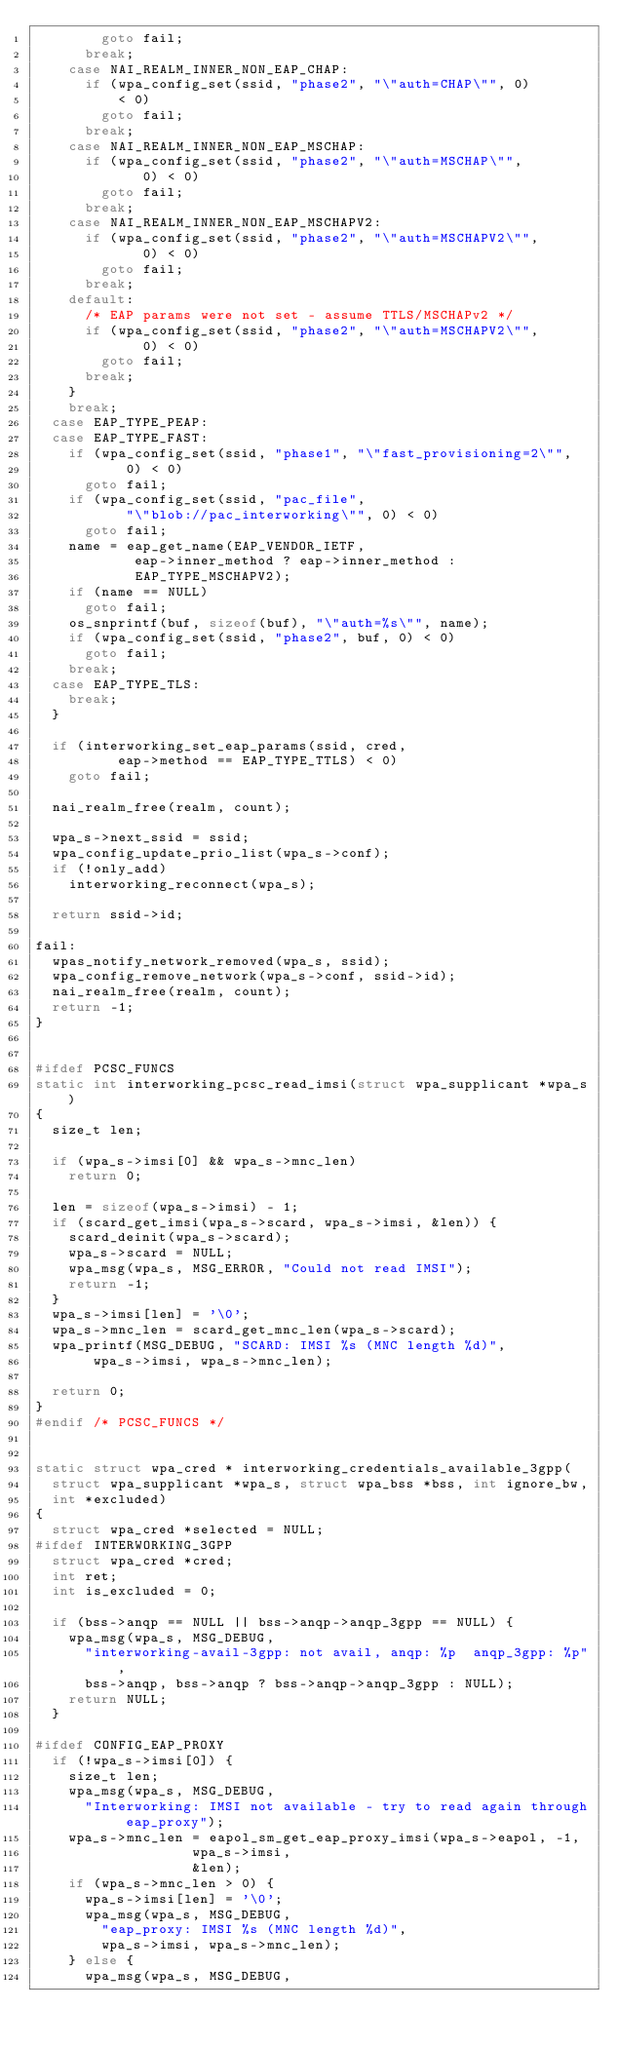Convert code to text. <code><loc_0><loc_0><loc_500><loc_500><_C_>				goto fail;
			break;
		case NAI_REALM_INNER_NON_EAP_CHAP:
			if (wpa_config_set(ssid, "phase2", "\"auth=CHAP\"", 0)
			    < 0)
				goto fail;
			break;
		case NAI_REALM_INNER_NON_EAP_MSCHAP:
			if (wpa_config_set(ssid, "phase2", "\"auth=MSCHAP\"",
					   0) < 0)
				goto fail;
			break;
		case NAI_REALM_INNER_NON_EAP_MSCHAPV2:
			if (wpa_config_set(ssid, "phase2", "\"auth=MSCHAPV2\"",
					   0) < 0)
				goto fail;
			break;
		default:
			/* EAP params were not set - assume TTLS/MSCHAPv2 */
			if (wpa_config_set(ssid, "phase2", "\"auth=MSCHAPV2\"",
					   0) < 0)
				goto fail;
			break;
		}
		break;
	case EAP_TYPE_PEAP:
	case EAP_TYPE_FAST:
		if (wpa_config_set(ssid, "phase1", "\"fast_provisioning=2\"",
				   0) < 0)
			goto fail;
		if (wpa_config_set(ssid, "pac_file",
				   "\"blob://pac_interworking\"", 0) < 0)
			goto fail;
		name = eap_get_name(EAP_VENDOR_IETF,
				    eap->inner_method ? eap->inner_method :
				    EAP_TYPE_MSCHAPV2);
		if (name == NULL)
			goto fail;
		os_snprintf(buf, sizeof(buf), "\"auth=%s\"", name);
		if (wpa_config_set(ssid, "phase2", buf, 0) < 0)
			goto fail;
		break;
	case EAP_TYPE_TLS:
		break;
	}

	if (interworking_set_eap_params(ssid, cred,
					eap->method == EAP_TYPE_TTLS) < 0)
		goto fail;

	nai_realm_free(realm, count);

	wpa_s->next_ssid = ssid;
	wpa_config_update_prio_list(wpa_s->conf);
	if (!only_add)
		interworking_reconnect(wpa_s);

	return ssid->id;

fail:
	wpas_notify_network_removed(wpa_s, ssid);
	wpa_config_remove_network(wpa_s->conf, ssid->id);
	nai_realm_free(realm, count);
	return -1;
}


#ifdef PCSC_FUNCS
static int interworking_pcsc_read_imsi(struct wpa_supplicant *wpa_s)
{
	size_t len;

	if (wpa_s->imsi[0] && wpa_s->mnc_len)
		return 0;

	len = sizeof(wpa_s->imsi) - 1;
	if (scard_get_imsi(wpa_s->scard, wpa_s->imsi, &len)) {
		scard_deinit(wpa_s->scard);
		wpa_s->scard = NULL;
		wpa_msg(wpa_s, MSG_ERROR, "Could not read IMSI");
		return -1;
	}
	wpa_s->imsi[len] = '\0';
	wpa_s->mnc_len = scard_get_mnc_len(wpa_s->scard);
	wpa_printf(MSG_DEBUG, "SCARD: IMSI %s (MNC length %d)",
		   wpa_s->imsi, wpa_s->mnc_len);

	return 0;
}
#endif /* PCSC_FUNCS */


static struct wpa_cred * interworking_credentials_available_3gpp(
	struct wpa_supplicant *wpa_s, struct wpa_bss *bss, int ignore_bw,
	int *excluded)
{
	struct wpa_cred *selected = NULL;
#ifdef INTERWORKING_3GPP
	struct wpa_cred *cred;
	int ret;
	int is_excluded = 0;

	if (bss->anqp == NULL || bss->anqp->anqp_3gpp == NULL) {
		wpa_msg(wpa_s, MSG_DEBUG,
			"interworking-avail-3gpp: not avail, anqp: %p  anqp_3gpp: %p",
			bss->anqp, bss->anqp ? bss->anqp->anqp_3gpp : NULL);
		return NULL;
	}

#ifdef CONFIG_EAP_PROXY
	if (!wpa_s->imsi[0]) {
		size_t len;
		wpa_msg(wpa_s, MSG_DEBUG,
			"Interworking: IMSI not available - try to read again through eap_proxy");
		wpa_s->mnc_len = eapol_sm_get_eap_proxy_imsi(wpa_s->eapol, -1,
							     wpa_s->imsi,
							     &len);
		if (wpa_s->mnc_len > 0) {
			wpa_s->imsi[len] = '\0';
			wpa_msg(wpa_s, MSG_DEBUG,
				"eap_proxy: IMSI %s (MNC length %d)",
				wpa_s->imsi, wpa_s->mnc_len);
		} else {
			wpa_msg(wpa_s, MSG_DEBUG,</code> 